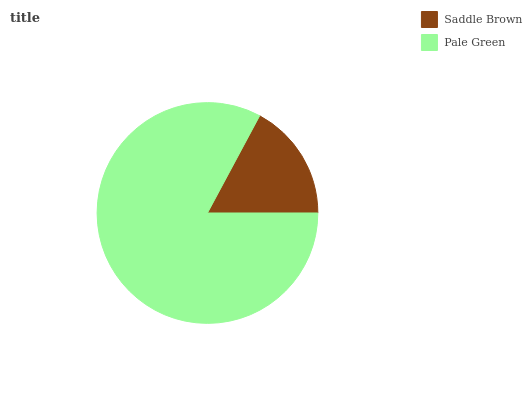Is Saddle Brown the minimum?
Answer yes or no. Yes. Is Pale Green the maximum?
Answer yes or no. Yes. Is Pale Green the minimum?
Answer yes or no. No. Is Pale Green greater than Saddle Brown?
Answer yes or no. Yes. Is Saddle Brown less than Pale Green?
Answer yes or no. Yes. Is Saddle Brown greater than Pale Green?
Answer yes or no. No. Is Pale Green less than Saddle Brown?
Answer yes or no. No. Is Pale Green the high median?
Answer yes or no. Yes. Is Saddle Brown the low median?
Answer yes or no. Yes. Is Saddle Brown the high median?
Answer yes or no. No. Is Pale Green the low median?
Answer yes or no. No. 